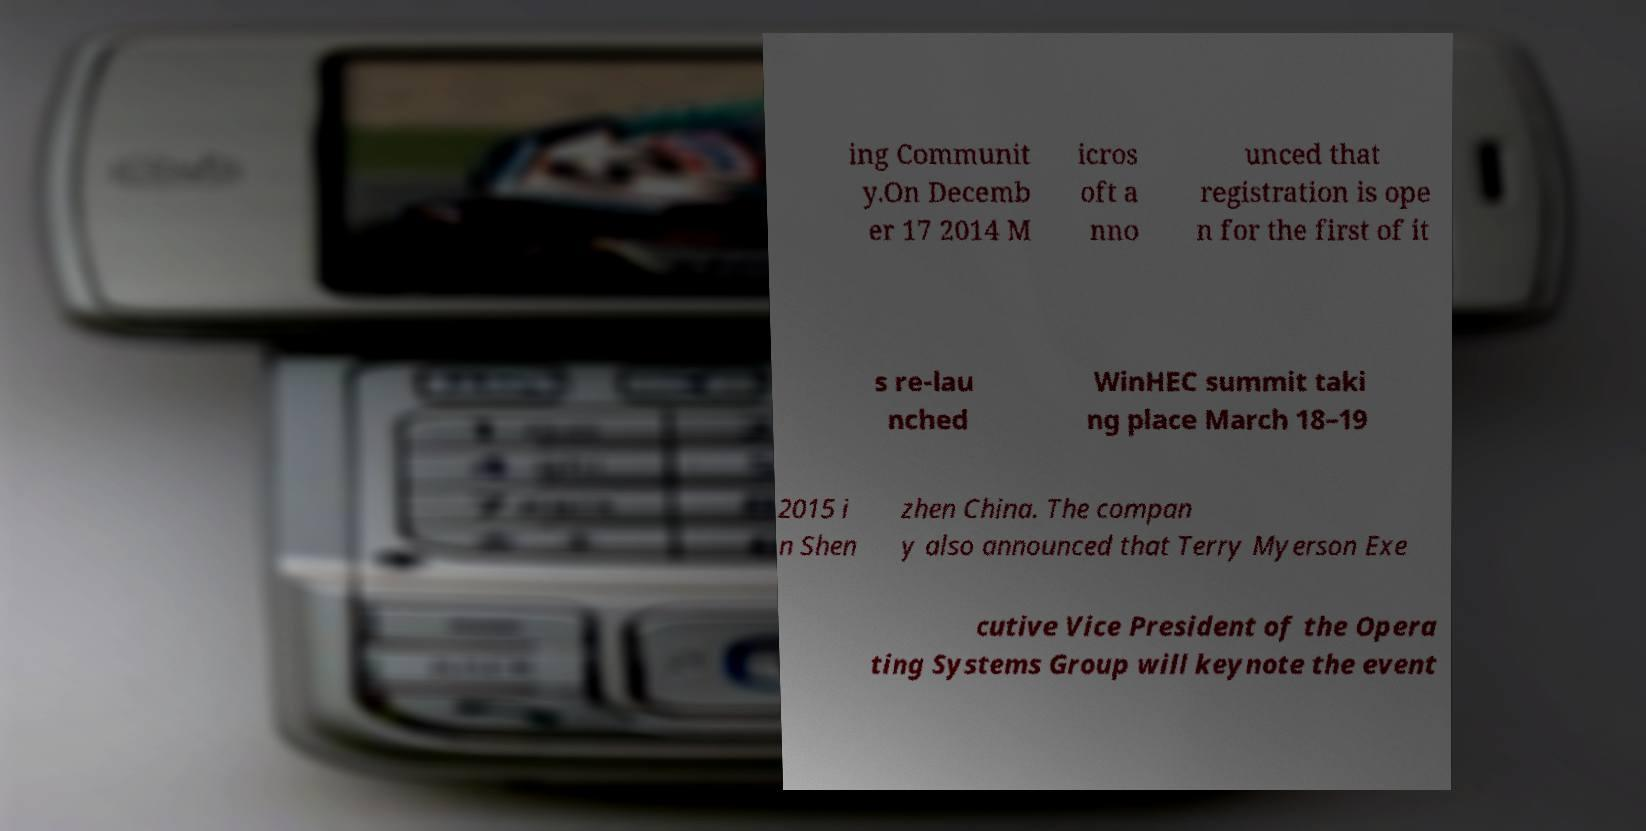There's text embedded in this image that I need extracted. Can you transcribe it verbatim? ing Communit y.On Decemb er 17 2014 M icros oft a nno unced that registration is ope n for the first of it s re-lau nched WinHEC summit taki ng place March 18–19 2015 i n Shen zhen China. The compan y also announced that Terry Myerson Exe cutive Vice President of the Opera ting Systems Group will keynote the event 